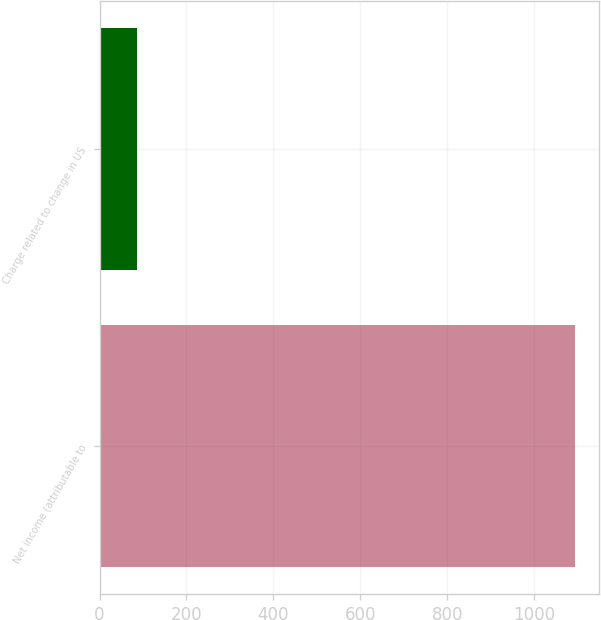Convert chart. <chart><loc_0><loc_0><loc_500><loc_500><bar_chart><fcel>Net income (attributable to<fcel>Charge related to change in US<nl><fcel>1095<fcel>85<nl></chart> 